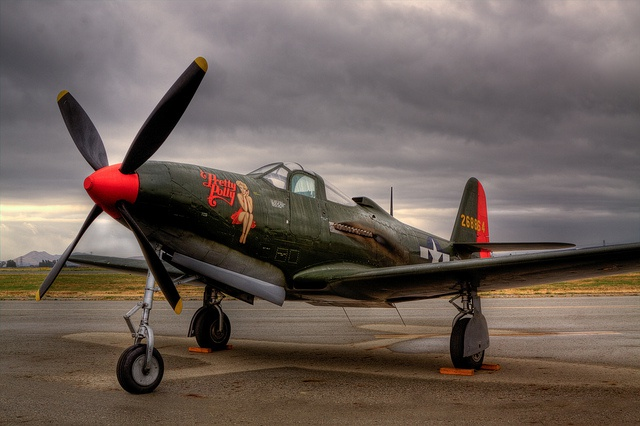Describe the objects in this image and their specific colors. I can see a airplane in gray, black, and maroon tones in this image. 